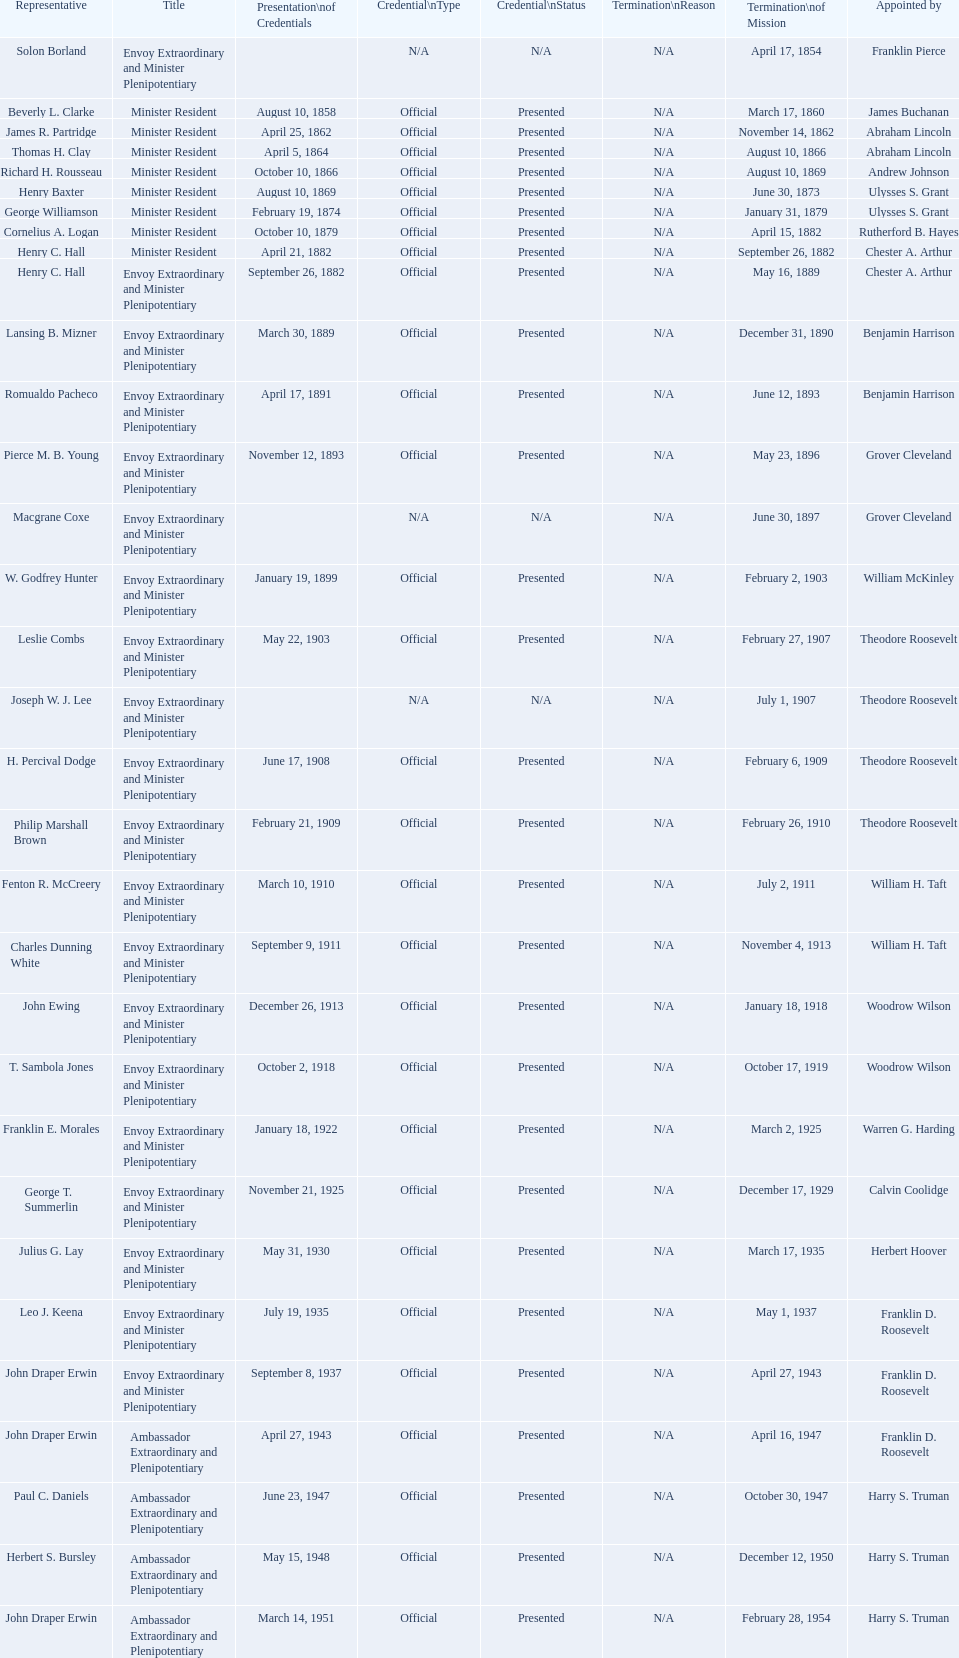Which reps were only appointed by franklin pierce? Solon Borland. 